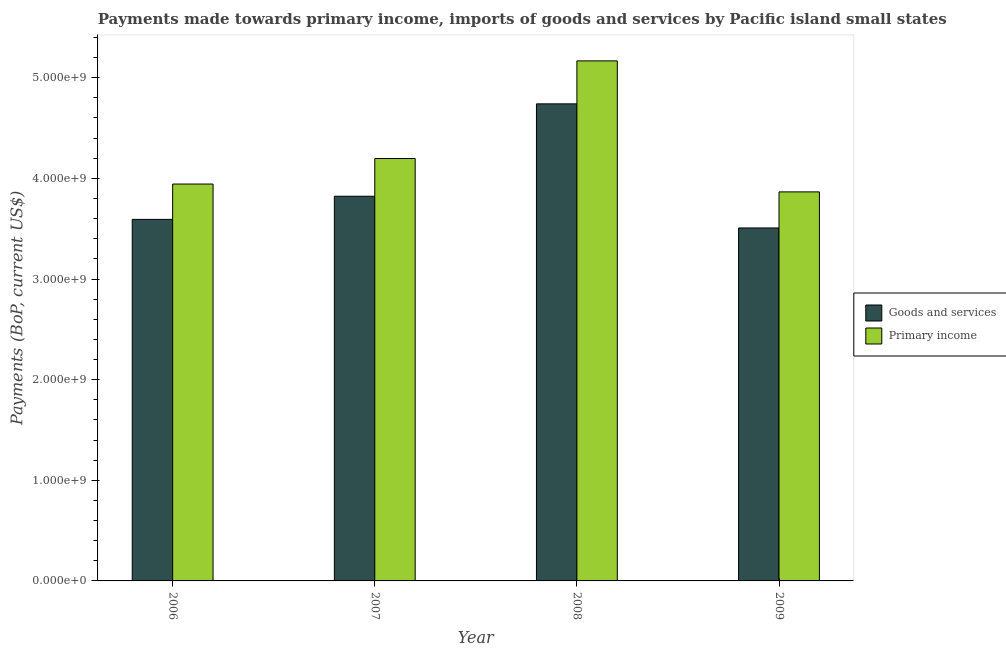How many different coloured bars are there?
Provide a short and direct response. 2. How many groups of bars are there?
Offer a very short reply. 4. Are the number of bars per tick equal to the number of legend labels?
Keep it short and to the point. Yes. Are the number of bars on each tick of the X-axis equal?
Provide a succinct answer. Yes. What is the payments made towards primary income in 2006?
Offer a terse response. 3.94e+09. Across all years, what is the maximum payments made towards primary income?
Your answer should be very brief. 5.17e+09. Across all years, what is the minimum payments made towards primary income?
Your response must be concise. 3.87e+09. What is the total payments made towards goods and services in the graph?
Make the answer very short. 1.57e+1. What is the difference between the payments made towards primary income in 2007 and that in 2009?
Keep it short and to the point. 3.32e+08. What is the difference between the payments made towards primary income in 2009 and the payments made towards goods and services in 2006?
Provide a short and direct response. -7.80e+07. What is the average payments made towards primary income per year?
Ensure brevity in your answer.  4.29e+09. In the year 2009, what is the difference between the payments made towards primary income and payments made towards goods and services?
Make the answer very short. 0. In how many years, is the payments made towards primary income greater than 5000000000 US$?
Make the answer very short. 1. What is the ratio of the payments made towards goods and services in 2007 to that in 2008?
Keep it short and to the point. 0.81. What is the difference between the highest and the second highest payments made towards primary income?
Make the answer very short. 9.70e+08. What is the difference between the highest and the lowest payments made towards goods and services?
Your response must be concise. 1.23e+09. Is the sum of the payments made towards goods and services in 2008 and 2009 greater than the maximum payments made towards primary income across all years?
Provide a short and direct response. Yes. What does the 1st bar from the left in 2006 represents?
Your response must be concise. Goods and services. What does the 2nd bar from the right in 2008 represents?
Keep it short and to the point. Goods and services. How many bars are there?
Provide a succinct answer. 8. Are all the bars in the graph horizontal?
Ensure brevity in your answer.  No. What is the difference between two consecutive major ticks on the Y-axis?
Your answer should be compact. 1.00e+09. Are the values on the major ticks of Y-axis written in scientific E-notation?
Offer a very short reply. Yes. Does the graph contain grids?
Offer a very short reply. No. What is the title of the graph?
Keep it short and to the point. Payments made towards primary income, imports of goods and services by Pacific island small states. What is the label or title of the Y-axis?
Provide a succinct answer. Payments (BoP, current US$). What is the Payments (BoP, current US$) in Goods and services in 2006?
Your response must be concise. 3.59e+09. What is the Payments (BoP, current US$) of Primary income in 2006?
Your answer should be very brief. 3.94e+09. What is the Payments (BoP, current US$) of Goods and services in 2007?
Give a very brief answer. 3.82e+09. What is the Payments (BoP, current US$) in Primary income in 2007?
Your response must be concise. 4.20e+09. What is the Payments (BoP, current US$) in Goods and services in 2008?
Your answer should be compact. 4.74e+09. What is the Payments (BoP, current US$) of Primary income in 2008?
Make the answer very short. 5.17e+09. What is the Payments (BoP, current US$) in Goods and services in 2009?
Give a very brief answer. 3.51e+09. What is the Payments (BoP, current US$) of Primary income in 2009?
Provide a succinct answer. 3.87e+09. Across all years, what is the maximum Payments (BoP, current US$) in Goods and services?
Offer a terse response. 4.74e+09. Across all years, what is the maximum Payments (BoP, current US$) in Primary income?
Ensure brevity in your answer.  5.17e+09. Across all years, what is the minimum Payments (BoP, current US$) of Goods and services?
Keep it short and to the point. 3.51e+09. Across all years, what is the minimum Payments (BoP, current US$) of Primary income?
Provide a short and direct response. 3.87e+09. What is the total Payments (BoP, current US$) of Goods and services in the graph?
Offer a terse response. 1.57e+1. What is the total Payments (BoP, current US$) of Primary income in the graph?
Keep it short and to the point. 1.72e+1. What is the difference between the Payments (BoP, current US$) in Goods and services in 2006 and that in 2007?
Your answer should be compact. -2.30e+08. What is the difference between the Payments (BoP, current US$) of Primary income in 2006 and that in 2007?
Your answer should be compact. -2.54e+08. What is the difference between the Payments (BoP, current US$) in Goods and services in 2006 and that in 2008?
Make the answer very short. -1.15e+09. What is the difference between the Payments (BoP, current US$) of Primary income in 2006 and that in 2008?
Give a very brief answer. -1.22e+09. What is the difference between the Payments (BoP, current US$) in Goods and services in 2006 and that in 2009?
Give a very brief answer. 8.52e+07. What is the difference between the Payments (BoP, current US$) of Primary income in 2006 and that in 2009?
Your response must be concise. 7.80e+07. What is the difference between the Payments (BoP, current US$) in Goods and services in 2007 and that in 2008?
Provide a short and direct response. -9.18e+08. What is the difference between the Payments (BoP, current US$) in Primary income in 2007 and that in 2008?
Your answer should be very brief. -9.70e+08. What is the difference between the Payments (BoP, current US$) of Goods and services in 2007 and that in 2009?
Give a very brief answer. 3.15e+08. What is the difference between the Payments (BoP, current US$) of Primary income in 2007 and that in 2009?
Offer a very short reply. 3.32e+08. What is the difference between the Payments (BoP, current US$) of Goods and services in 2008 and that in 2009?
Give a very brief answer. 1.23e+09. What is the difference between the Payments (BoP, current US$) of Primary income in 2008 and that in 2009?
Provide a short and direct response. 1.30e+09. What is the difference between the Payments (BoP, current US$) of Goods and services in 2006 and the Payments (BoP, current US$) of Primary income in 2007?
Ensure brevity in your answer.  -6.05e+08. What is the difference between the Payments (BoP, current US$) of Goods and services in 2006 and the Payments (BoP, current US$) of Primary income in 2008?
Offer a terse response. -1.57e+09. What is the difference between the Payments (BoP, current US$) of Goods and services in 2006 and the Payments (BoP, current US$) of Primary income in 2009?
Give a very brief answer. -2.73e+08. What is the difference between the Payments (BoP, current US$) in Goods and services in 2007 and the Payments (BoP, current US$) in Primary income in 2008?
Ensure brevity in your answer.  -1.35e+09. What is the difference between the Payments (BoP, current US$) of Goods and services in 2007 and the Payments (BoP, current US$) of Primary income in 2009?
Offer a very short reply. -4.32e+07. What is the difference between the Payments (BoP, current US$) in Goods and services in 2008 and the Payments (BoP, current US$) in Primary income in 2009?
Your answer should be compact. 8.75e+08. What is the average Payments (BoP, current US$) in Goods and services per year?
Provide a short and direct response. 3.92e+09. What is the average Payments (BoP, current US$) of Primary income per year?
Make the answer very short. 4.29e+09. In the year 2006, what is the difference between the Payments (BoP, current US$) of Goods and services and Payments (BoP, current US$) of Primary income?
Your response must be concise. -3.51e+08. In the year 2007, what is the difference between the Payments (BoP, current US$) of Goods and services and Payments (BoP, current US$) of Primary income?
Your answer should be very brief. -3.75e+08. In the year 2008, what is the difference between the Payments (BoP, current US$) in Goods and services and Payments (BoP, current US$) in Primary income?
Make the answer very short. -4.27e+08. In the year 2009, what is the difference between the Payments (BoP, current US$) of Goods and services and Payments (BoP, current US$) of Primary income?
Your response must be concise. -3.58e+08. What is the ratio of the Payments (BoP, current US$) in Goods and services in 2006 to that in 2007?
Your response must be concise. 0.94. What is the ratio of the Payments (BoP, current US$) in Primary income in 2006 to that in 2007?
Your answer should be very brief. 0.94. What is the ratio of the Payments (BoP, current US$) of Goods and services in 2006 to that in 2008?
Give a very brief answer. 0.76. What is the ratio of the Payments (BoP, current US$) in Primary income in 2006 to that in 2008?
Give a very brief answer. 0.76. What is the ratio of the Payments (BoP, current US$) in Goods and services in 2006 to that in 2009?
Provide a short and direct response. 1.02. What is the ratio of the Payments (BoP, current US$) of Primary income in 2006 to that in 2009?
Your answer should be compact. 1.02. What is the ratio of the Payments (BoP, current US$) of Goods and services in 2007 to that in 2008?
Ensure brevity in your answer.  0.81. What is the ratio of the Payments (BoP, current US$) of Primary income in 2007 to that in 2008?
Your answer should be very brief. 0.81. What is the ratio of the Payments (BoP, current US$) of Goods and services in 2007 to that in 2009?
Ensure brevity in your answer.  1.09. What is the ratio of the Payments (BoP, current US$) in Primary income in 2007 to that in 2009?
Your answer should be very brief. 1.09. What is the ratio of the Payments (BoP, current US$) in Goods and services in 2008 to that in 2009?
Provide a succinct answer. 1.35. What is the ratio of the Payments (BoP, current US$) in Primary income in 2008 to that in 2009?
Offer a very short reply. 1.34. What is the difference between the highest and the second highest Payments (BoP, current US$) of Goods and services?
Provide a succinct answer. 9.18e+08. What is the difference between the highest and the second highest Payments (BoP, current US$) of Primary income?
Offer a very short reply. 9.70e+08. What is the difference between the highest and the lowest Payments (BoP, current US$) of Goods and services?
Offer a terse response. 1.23e+09. What is the difference between the highest and the lowest Payments (BoP, current US$) in Primary income?
Your answer should be compact. 1.30e+09. 